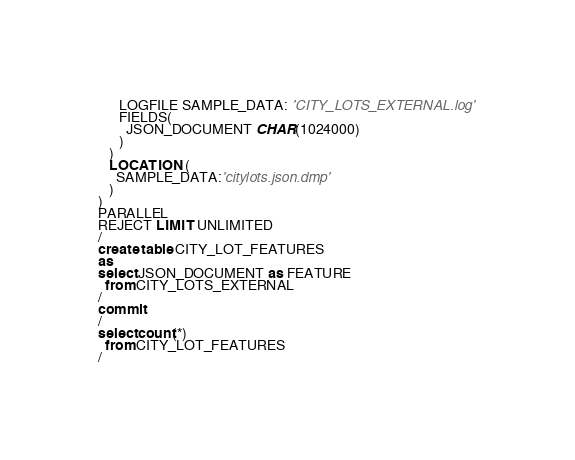<code> <loc_0><loc_0><loc_500><loc_500><_SQL_>      LOGFILE SAMPLE_DATA: 'CITY_LOTS_EXTERNAL.log'
      FIELDS(
        JSON_DOCUMENT CHAR(1024000)
      ) 
   )
   LOCATION (
     SAMPLE_DATA:'citylots.json.dmp'
   )
)
PARALLEL
REJECT LIMIT UNLIMITED
/
create table CITY_LOT_FEATURES
as
select JSON_DOCUMENT as FEATURE
  from CITY_LOTS_EXTERNAL
/
commit
/
select count(*) 
  from CITY_LOT_FEATURES
/
</code> 